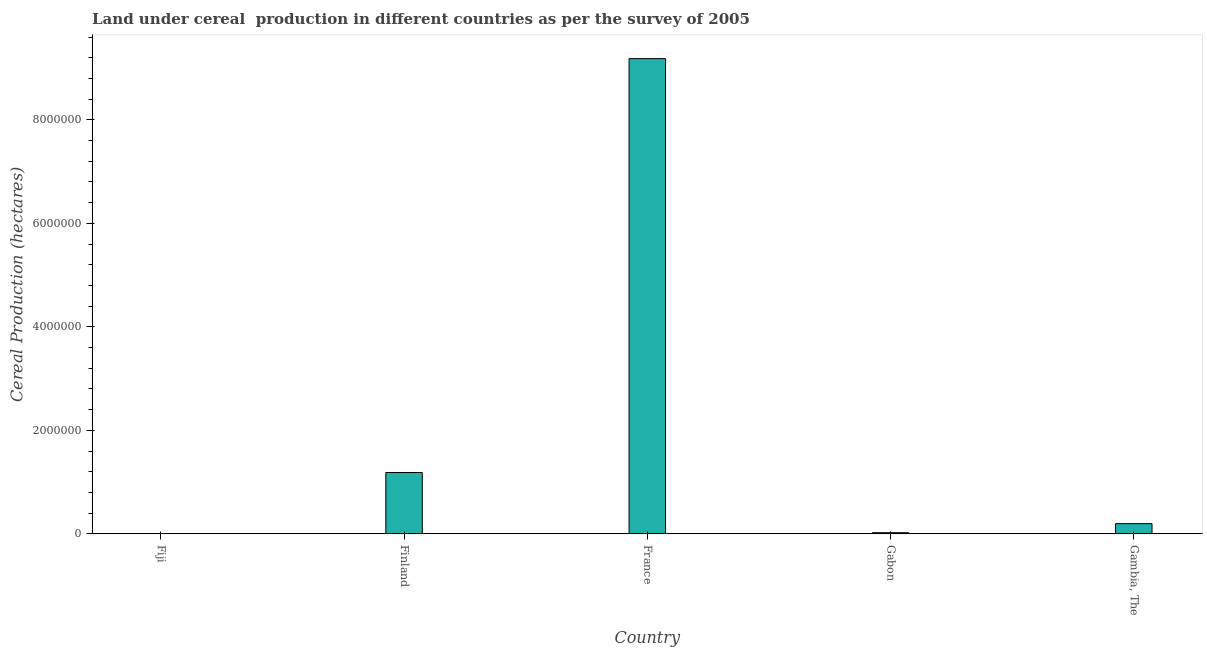What is the title of the graph?
Provide a short and direct response. Land under cereal  production in different countries as per the survey of 2005. What is the label or title of the X-axis?
Your answer should be very brief. Country. What is the label or title of the Y-axis?
Your answer should be compact. Cereal Production (hectares). What is the land under cereal production in Gabon?
Your answer should be very brief. 2.25e+04. Across all countries, what is the maximum land under cereal production?
Give a very brief answer. 9.18e+06. Across all countries, what is the minimum land under cereal production?
Keep it short and to the point. 6763. In which country was the land under cereal production maximum?
Offer a terse response. France. In which country was the land under cereal production minimum?
Offer a very short reply. Fiji. What is the sum of the land under cereal production?
Make the answer very short. 1.06e+07. What is the difference between the land under cereal production in France and Gabon?
Ensure brevity in your answer.  9.16e+06. What is the average land under cereal production per country?
Offer a terse response. 2.12e+06. What is the median land under cereal production?
Your answer should be very brief. 1.98e+05. What is the ratio of the land under cereal production in Fiji to that in Gabon?
Keep it short and to the point. 0.3. What is the difference between the highest and the second highest land under cereal production?
Offer a very short reply. 8.00e+06. Is the sum of the land under cereal production in Fiji and Gabon greater than the maximum land under cereal production across all countries?
Provide a succinct answer. No. What is the difference between the highest and the lowest land under cereal production?
Make the answer very short. 9.18e+06. In how many countries, is the land under cereal production greater than the average land under cereal production taken over all countries?
Give a very brief answer. 1. Are all the bars in the graph horizontal?
Offer a terse response. No. How many countries are there in the graph?
Provide a succinct answer. 5. Are the values on the major ticks of Y-axis written in scientific E-notation?
Keep it short and to the point. No. What is the Cereal Production (hectares) of Fiji?
Your answer should be very brief. 6763. What is the Cereal Production (hectares) in Finland?
Keep it short and to the point. 1.19e+06. What is the Cereal Production (hectares) of France?
Your answer should be compact. 9.18e+06. What is the Cereal Production (hectares) of Gabon?
Provide a succinct answer. 2.25e+04. What is the Cereal Production (hectares) of Gambia, The?
Make the answer very short. 1.98e+05. What is the difference between the Cereal Production (hectares) in Fiji and Finland?
Your answer should be compact. -1.18e+06. What is the difference between the Cereal Production (hectares) in Fiji and France?
Ensure brevity in your answer.  -9.18e+06. What is the difference between the Cereal Production (hectares) in Fiji and Gabon?
Provide a short and direct response. -1.57e+04. What is the difference between the Cereal Production (hectares) in Fiji and Gambia, The?
Offer a terse response. -1.91e+05. What is the difference between the Cereal Production (hectares) in Finland and France?
Offer a terse response. -8.00e+06. What is the difference between the Cereal Production (hectares) in Finland and Gabon?
Give a very brief answer. 1.16e+06. What is the difference between the Cereal Production (hectares) in Finland and Gambia, The?
Provide a short and direct response. 9.88e+05. What is the difference between the Cereal Production (hectares) in France and Gabon?
Give a very brief answer. 9.16e+06. What is the difference between the Cereal Production (hectares) in France and Gambia, The?
Give a very brief answer. 8.98e+06. What is the difference between the Cereal Production (hectares) in Gabon and Gambia, The?
Keep it short and to the point. -1.75e+05. What is the ratio of the Cereal Production (hectares) in Fiji to that in Finland?
Provide a succinct answer. 0.01. What is the ratio of the Cereal Production (hectares) in Fiji to that in Gabon?
Keep it short and to the point. 0.3. What is the ratio of the Cereal Production (hectares) in Fiji to that in Gambia, The?
Give a very brief answer. 0.03. What is the ratio of the Cereal Production (hectares) in Finland to that in France?
Your response must be concise. 0.13. What is the ratio of the Cereal Production (hectares) in Finland to that in Gabon?
Make the answer very short. 52.7. What is the ratio of the Cereal Production (hectares) in Finland to that in Gambia, The?
Make the answer very short. 6. What is the ratio of the Cereal Production (hectares) in France to that in Gabon?
Make the answer very short. 408.1. What is the ratio of the Cereal Production (hectares) in France to that in Gambia, The?
Your response must be concise. 46.47. What is the ratio of the Cereal Production (hectares) in Gabon to that in Gambia, The?
Make the answer very short. 0.11. 